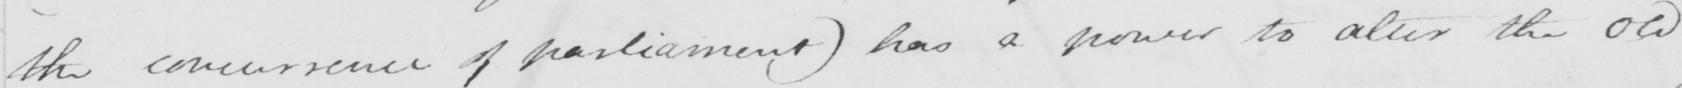What does this handwritten line say? the concurrence of parliament )  has a power to alter the old 